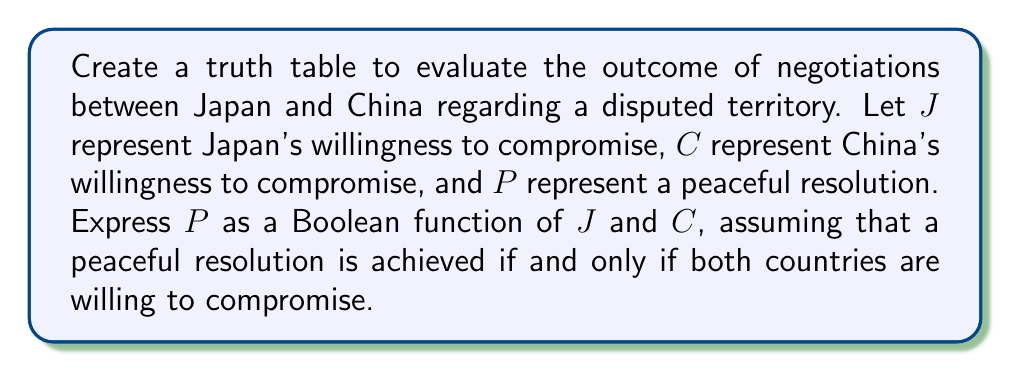Help me with this question. 1. Define the variables:
   $J$: Japan's willingness to compromise (1 = willing, 0 = unwilling)
   $C$: China's willingness to compromise (1 = willing, 0 = unwilling)
   $P$: Peaceful resolution (1 = achieved, 0 = not achieved)

2. Express $P$ as a Boolean function of $J$ and $C$:
   $P = J \land C$

3. Create the truth table:
   $$
   \begin{array}{|c|c|c|}
   \hline
   J & C & P \\
   \hline
   0 & 0 & 0 \\
   0 & 1 & 0 \\
   1 & 0 & 0 \\
   1 & 1 & 1 \\
   \hline
   \end{array}
   $$

4. Explanation of each row:
   - When $J = 0$ and $C = 0$, neither country is willing to compromise, so $P = 0$.
   - When $J = 0$ and $C = 1$, only China is willing to compromise, so $P = 0$.
   - When $J = 1$ and $C = 0$, only Japan is willing to compromise, so $P = 0$.
   - When $J = 1$ and $C = 1$, both countries are willing to compromise, so $P = 1$.

5. The Boolean function $P = J \land C$ accurately represents the conditions for a peaceful resolution, as it is true (1) only when both $J$ and $C$ are true (1).
Answer: $P = J \land C$ 